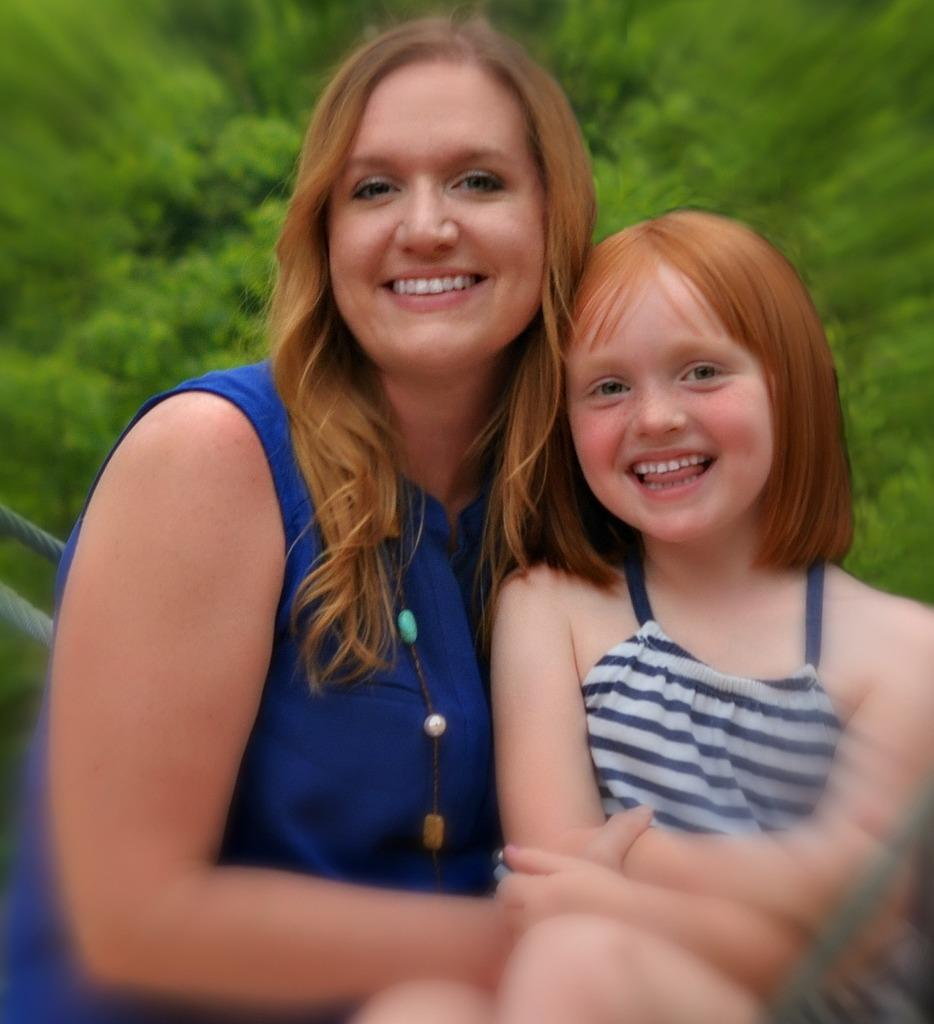Who is the main subject in the image? There is a woman in the image. What is the woman wearing? The woman is wearing a blue dress. Who is the woman with in the image? The woman is sitting with a small girl. What is the emotional expression of the woman and the small girl? They are both smiling. What are they doing in the image? They are giving a pose to the camera. What can be seen in the background of the image? There is a background of green plants in the image. What type of credit card is visible in the image? There is no credit card visible in the image. What is the tin doing in the image? There is no tin present in the image. 